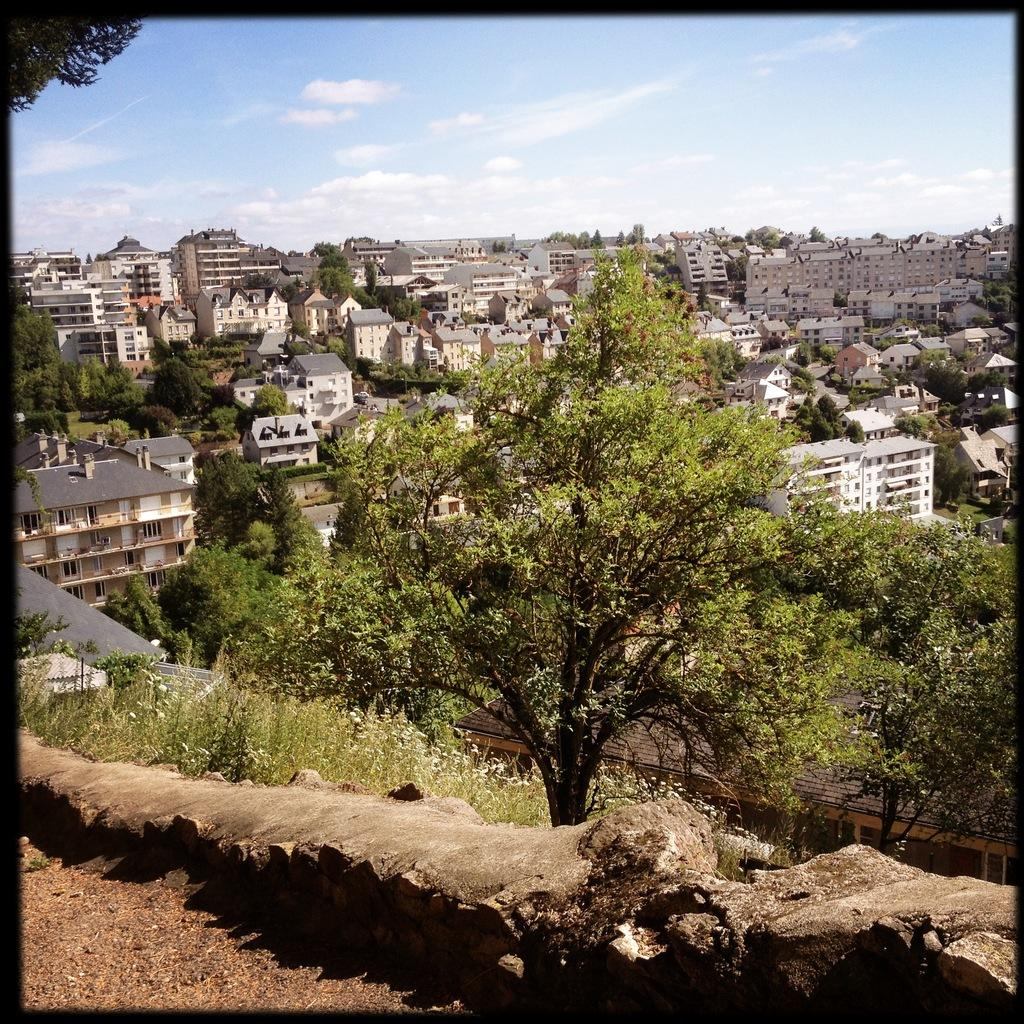What type of structure can be seen in the image? There is a fence in the image. What other natural elements are present in the image? There are trees in the image. What type of man-made structures can be seen in the image? There are houses and buildings in the image. What part of the natural environment is visible in the image? The sky is visible in the image. Can you see a snake slithering through the grass in the image? There is no snake present in the image. Is there a tiger roaming around the houses in the image? There is no tiger present in the image. 